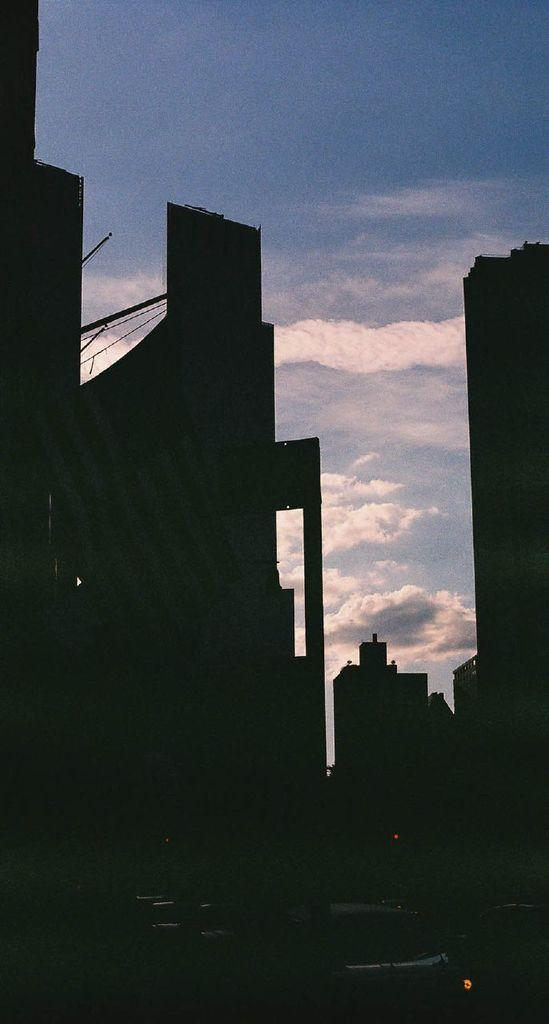What type of structures can be seen in the image? There are buildings in the image. What part of the natural environment is visible in the image? The sky is visible in the background of the image. What suggestion does the sky make in the image? The sky does not make any suggestions in the image; it is simply a part of the background. 